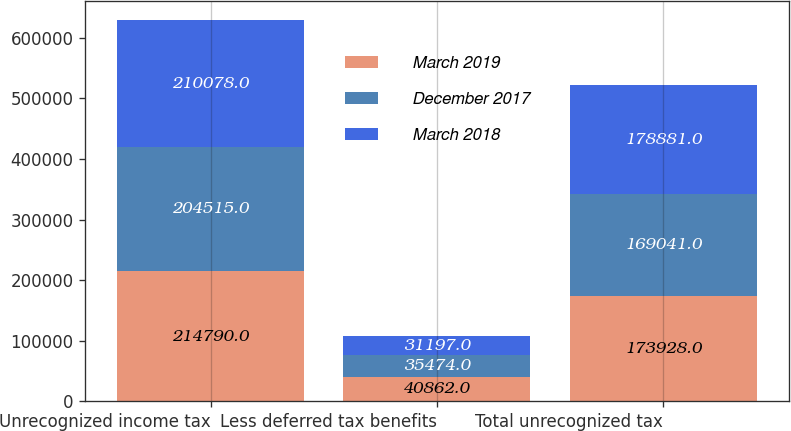Convert chart. <chart><loc_0><loc_0><loc_500><loc_500><stacked_bar_chart><ecel><fcel>Unrecognized income tax<fcel>Less deferred tax benefits<fcel>Total unrecognized tax<nl><fcel>March 2019<fcel>214790<fcel>40862<fcel>173928<nl><fcel>December 2017<fcel>204515<fcel>35474<fcel>169041<nl><fcel>March 2018<fcel>210078<fcel>31197<fcel>178881<nl></chart> 